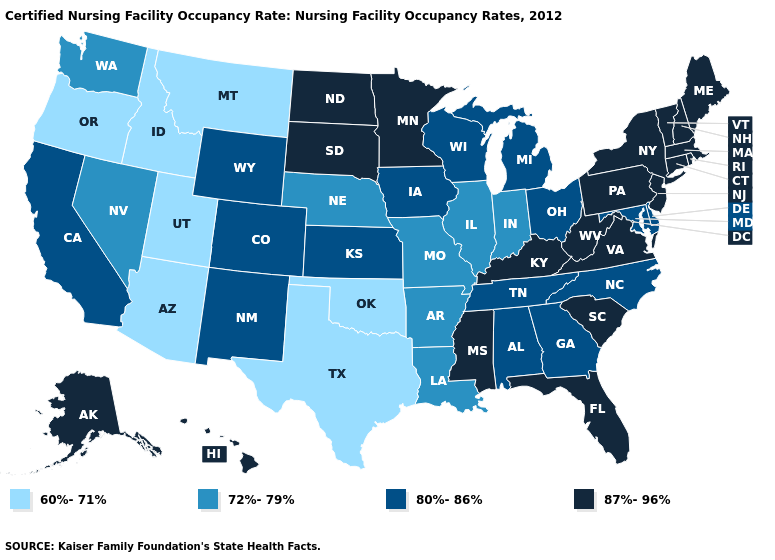How many symbols are there in the legend?
Be succinct. 4. What is the lowest value in states that border Mississippi?
Concise answer only. 72%-79%. Name the states that have a value in the range 72%-79%?
Give a very brief answer. Arkansas, Illinois, Indiana, Louisiana, Missouri, Nebraska, Nevada, Washington. Among the states that border Nebraska , does Missouri have the lowest value?
Keep it brief. Yes. Does the map have missing data?
Keep it brief. No. What is the value of Texas?
Give a very brief answer. 60%-71%. What is the value of Pennsylvania?
Concise answer only. 87%-96%. Which states have the lowest value in the West?
Concise answer only. Arizona, Idaho, Montana, Oregon, Utah. Does Virginia have the highest value in the USA?
Write a very short answer. Yes. What is the value of Maine?
Be succinct. 87%-96%. Name the states that have a value in the range 80%-86%?
Write a very short answer. Alabama, California, Colorado, Delaware, Georgia, Iowa, Kansas, Maryland, Michigan, New Mexico, North Carolina, Ohio, Tennessee, Wisconsin, Wyoming. What is the value of Idaho?
Quick response, please. 60%-71%. What is the value of Hawaii?
Give a very brief answer. 87%-96%. What is the highest value in states that border Alabama?
Concise answer only. 87%-96%. Does the map have missing data?
Concise answer only. No. 